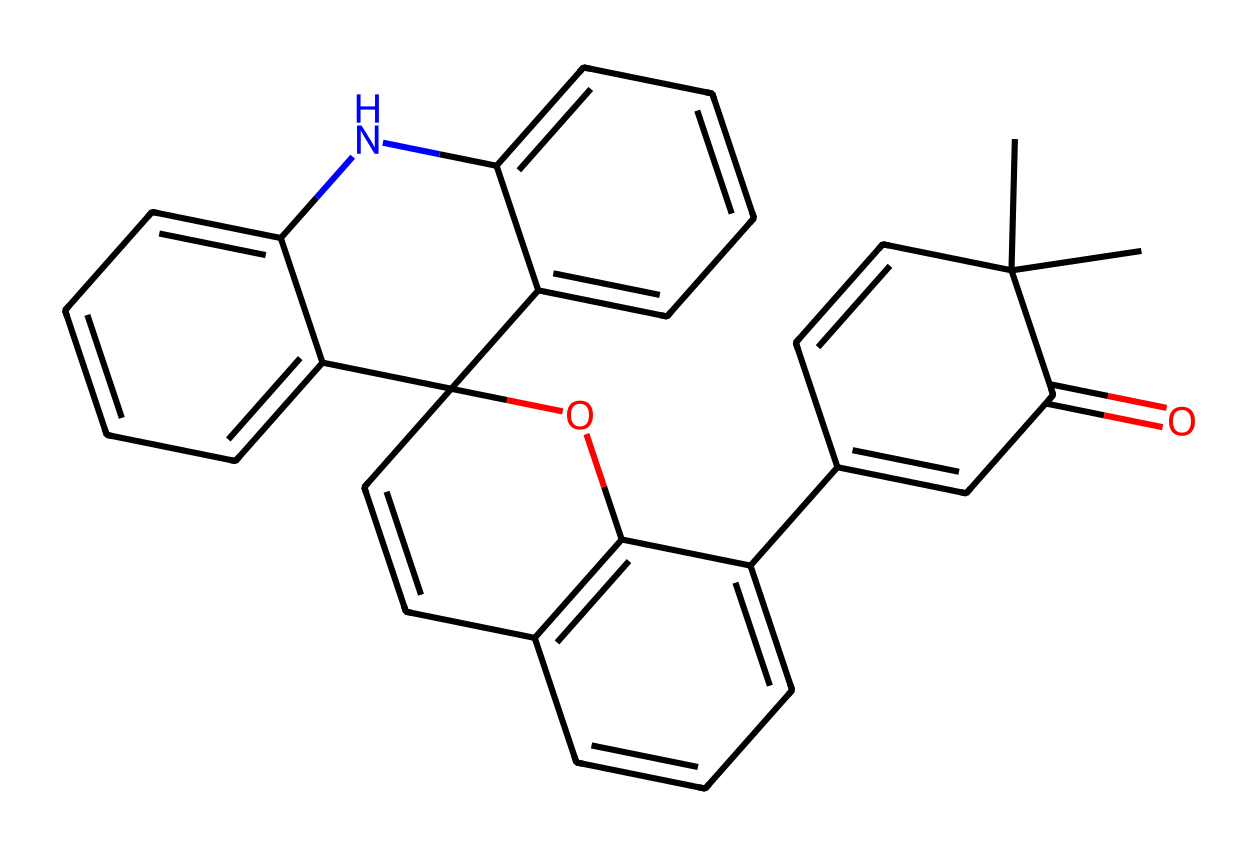What is the name of this chemical? Based on its structure and features, it corresponds to spiropyran, which is a known photochromic compound. The specific arrangement of atoms and functional groups verifies its identity.
Answer: spiropyran How many rings are present in this molecule? Examining the structure, I can identify multiple cyclic components. Upon counting, there are four distinct rings clearly indicated in the chemical structure.
Answer: four What functional groups are present in this compound? This molecule exhibits various functional groups. Specifically, I can see a carbonyl group (C=O) and an ether (C-O-C) linkage, both common in spiropyran derivatives.
Answer: carbonyl and ether What is the molecular formula of spiropyran represented here? Analyzing the structure, I can count the atoms present: 24 carbon (C), 23 hydrogen (H), 2 oxygen (O), and 1 nitrogen (N) atom, which helps me deduce the molecular formula as C24H23N1O2.
Answer: C24H23NO2 What role do the double bonds play in this chemical? The presence of double bonds contributes to the photochromic properties of spiropyran. They allow for the electronic transitions that facilitate its reversible switching between colored and colorless forms upon exposure to light.
Answer: photochromic properties How does the nitrogen in this structure influence its properties? The nitrogen atom introduces basicity and can influence the electronic properties of the molecule, potentially affecting its reactivity and interaction with light, which is crucial for its function in smart windows.
Answer: affects reactivity 